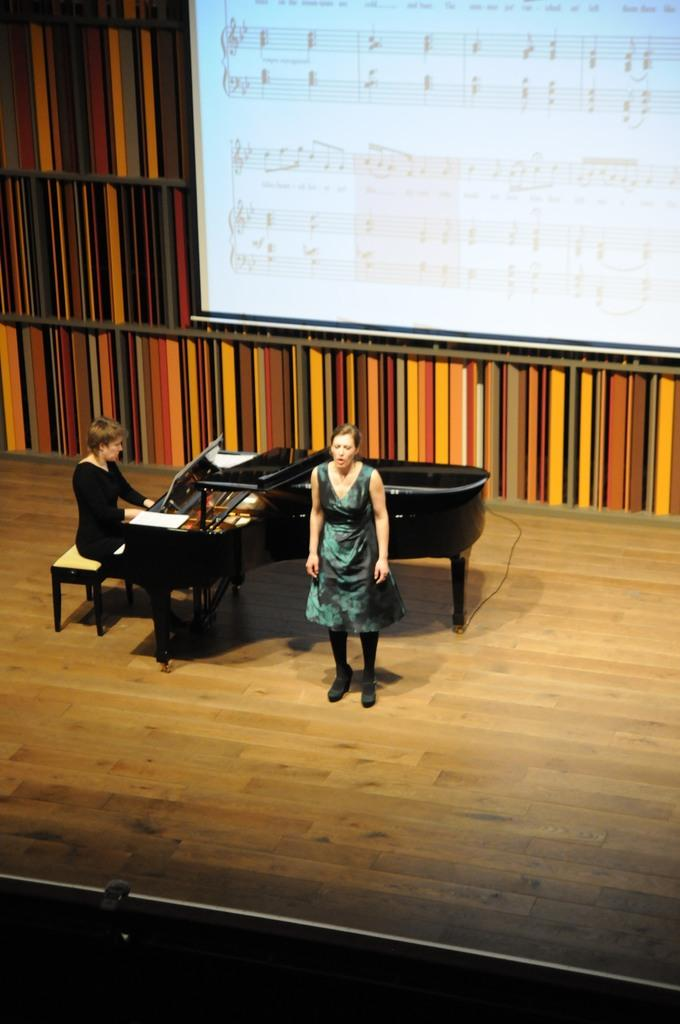How many women are in the image? There are two women in the image. What are the positions of the women in the image? One woman is standing, and the other is sitting. Where is the sitting woman located? The sitting woman is on a bench. What is in front of the bench? There is a piano in front of the bench. What can be seen in the background of the image? There is a wall and a screen in the background of the image. What type of lawyer is sitting next to the piano in the image? There is no lawyer present in the image; it features two women, one standing and one sitting on a bench in front of a piano. How does the screen roll in the image? The screen does not roll in the image; it is stationary in the background. 